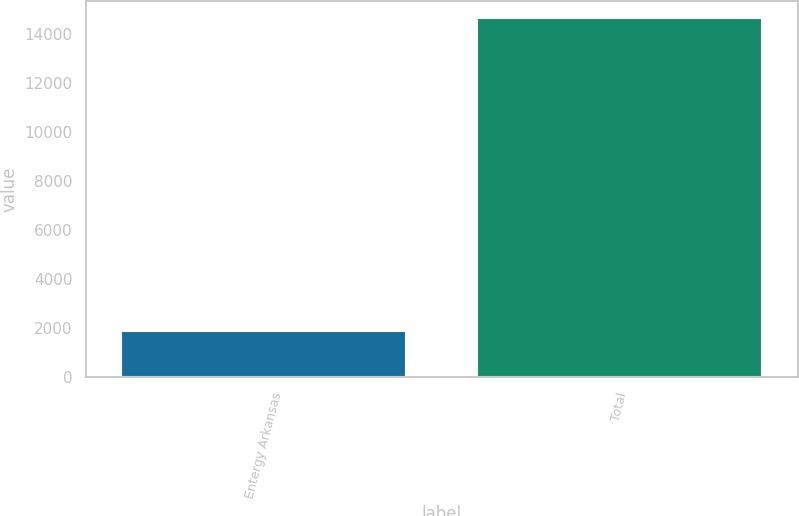<chart> <loc_0><loc_0><loc_500><loc_500><bar_chart><fcel>Entergy Arkansas<fcel>Total<nl><fcel>1883<fcel>14631<nl></chart> 